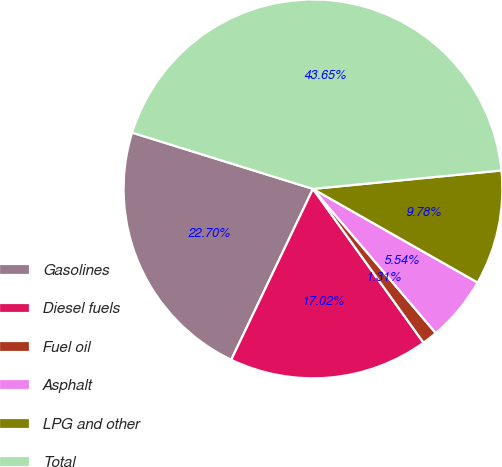<chart> <loc_0><loc_0><loc_500><loc_500><pie_chart><fcel>Gasolines<fcel>Diesel fuels<fcel>Fuel oil<fcel>Asphalt<fcel>LPG and other<fcel>Total<nl><fcel>22.7%<fcel>17.02%<fcel>1.31%<fcel>5.54%<fcel>9.78%<fcel>43.65%<nl></chart> 